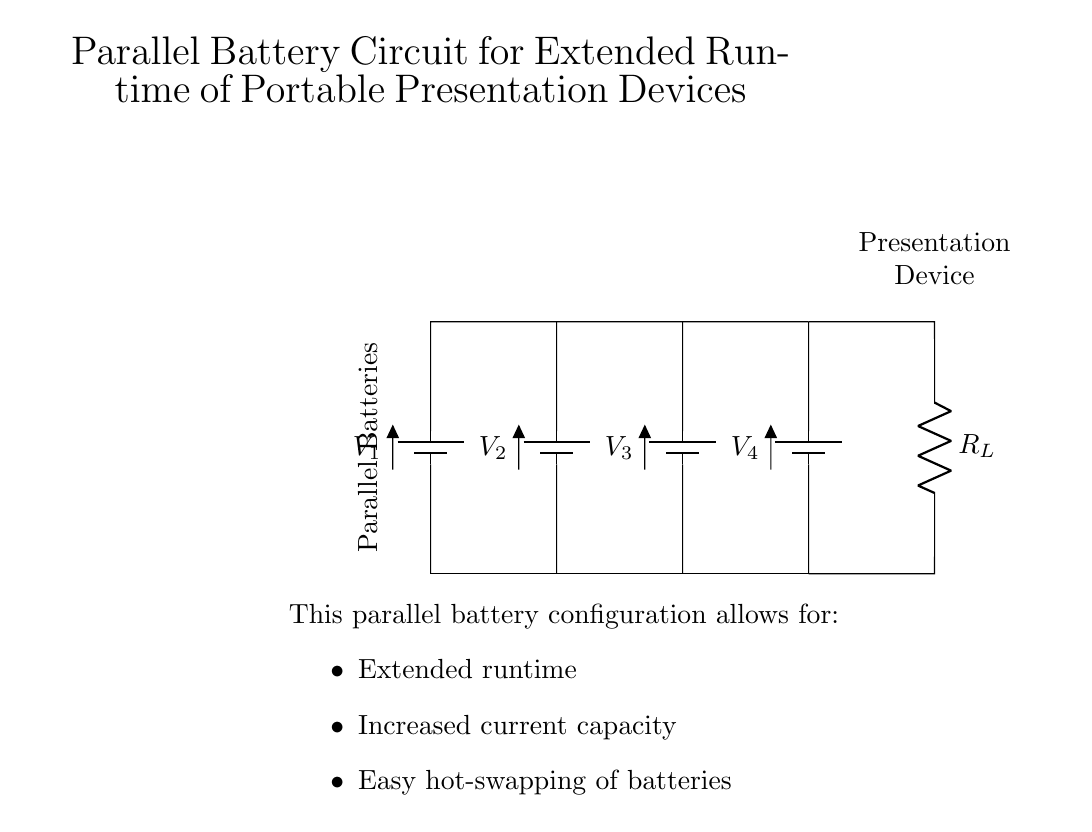What type of circuit is shown? The circuit is a parallel battery configuration, indicated by multiple batteries connected alongside each other with a common connection at the load.
Answer: Parallel What are the components in this circuit? The components are four batteries, a resistor representing the load, and connecting wires that link all components together.
Answer: Batteries and Resistor What is the role of the load in this circuit? The load, represented by the resistor, consumes power from the batteries, allowing the portable presentation device to function while the batteries provide a combined power source.
Answer: Power consumption How many batteries are used in parallel? There are four batteries arranged in parallel, which can be clearly seen as multiple battery symbols connected to the same nodes at the top and bottom of the circuit.
Answer: Four What advantage does the parallel configuration have regarding runtime? The parallel configuration allows for extended runtime because it combines the capacities of all batteries while maintaining the same voltage, effectively prolonging the power availability to the load.
Answer: Extended runtime What happens when one battery is removed in this configuration? When one battery is removed, the circuit continues to function with the remaining batteries, demonstrating the advantage of easy hot-swapping without interrupting the power supply to the load.
Answer: Hot-swapping What is the voltage across the load? The voltage across the load remains the same as the voltage of any individual battery since they are arranged in parallel, allowing for consistent voltage across the load terminals.
Answer: Same as individual battery 